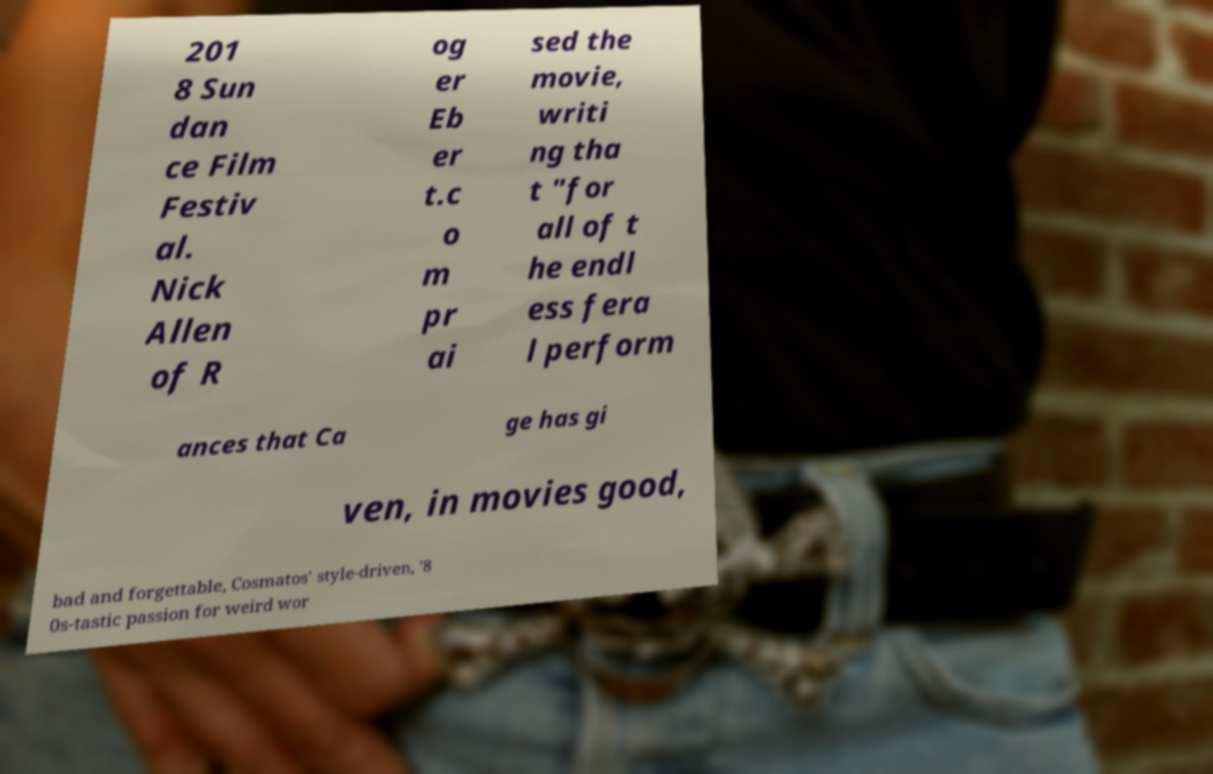There's text embedded in this image that I need extracted. Can you transcribe it verbatim? 201 8 Sun dan ce Film Festiv al. Nick Allen of R og er Eb er t.c o m pr ai sed the movie, writi ng tha t "for all of t he endl ess fera l perform ances that Ca ge has gi ven, in movies good, bad and forgettable, Cosmatos' style-driven, '8 0s-tastic passion for weird wor 